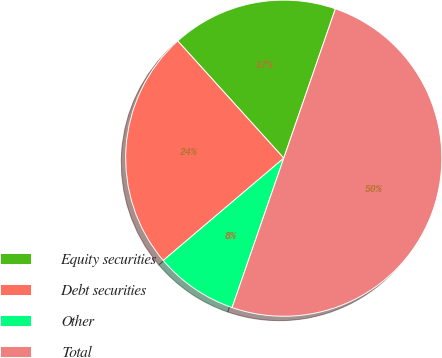Convert chart. <chart><loc_0><loc_0><loc_500><loc_500><pie_chart><fcel>Equity securities<fcel>Debt securities<fcel>Other<fcel>Total<nl><fcel>17.0%<fcel>24.5%<fcel>8.5%<fcel>50.0%<nl></chart> 